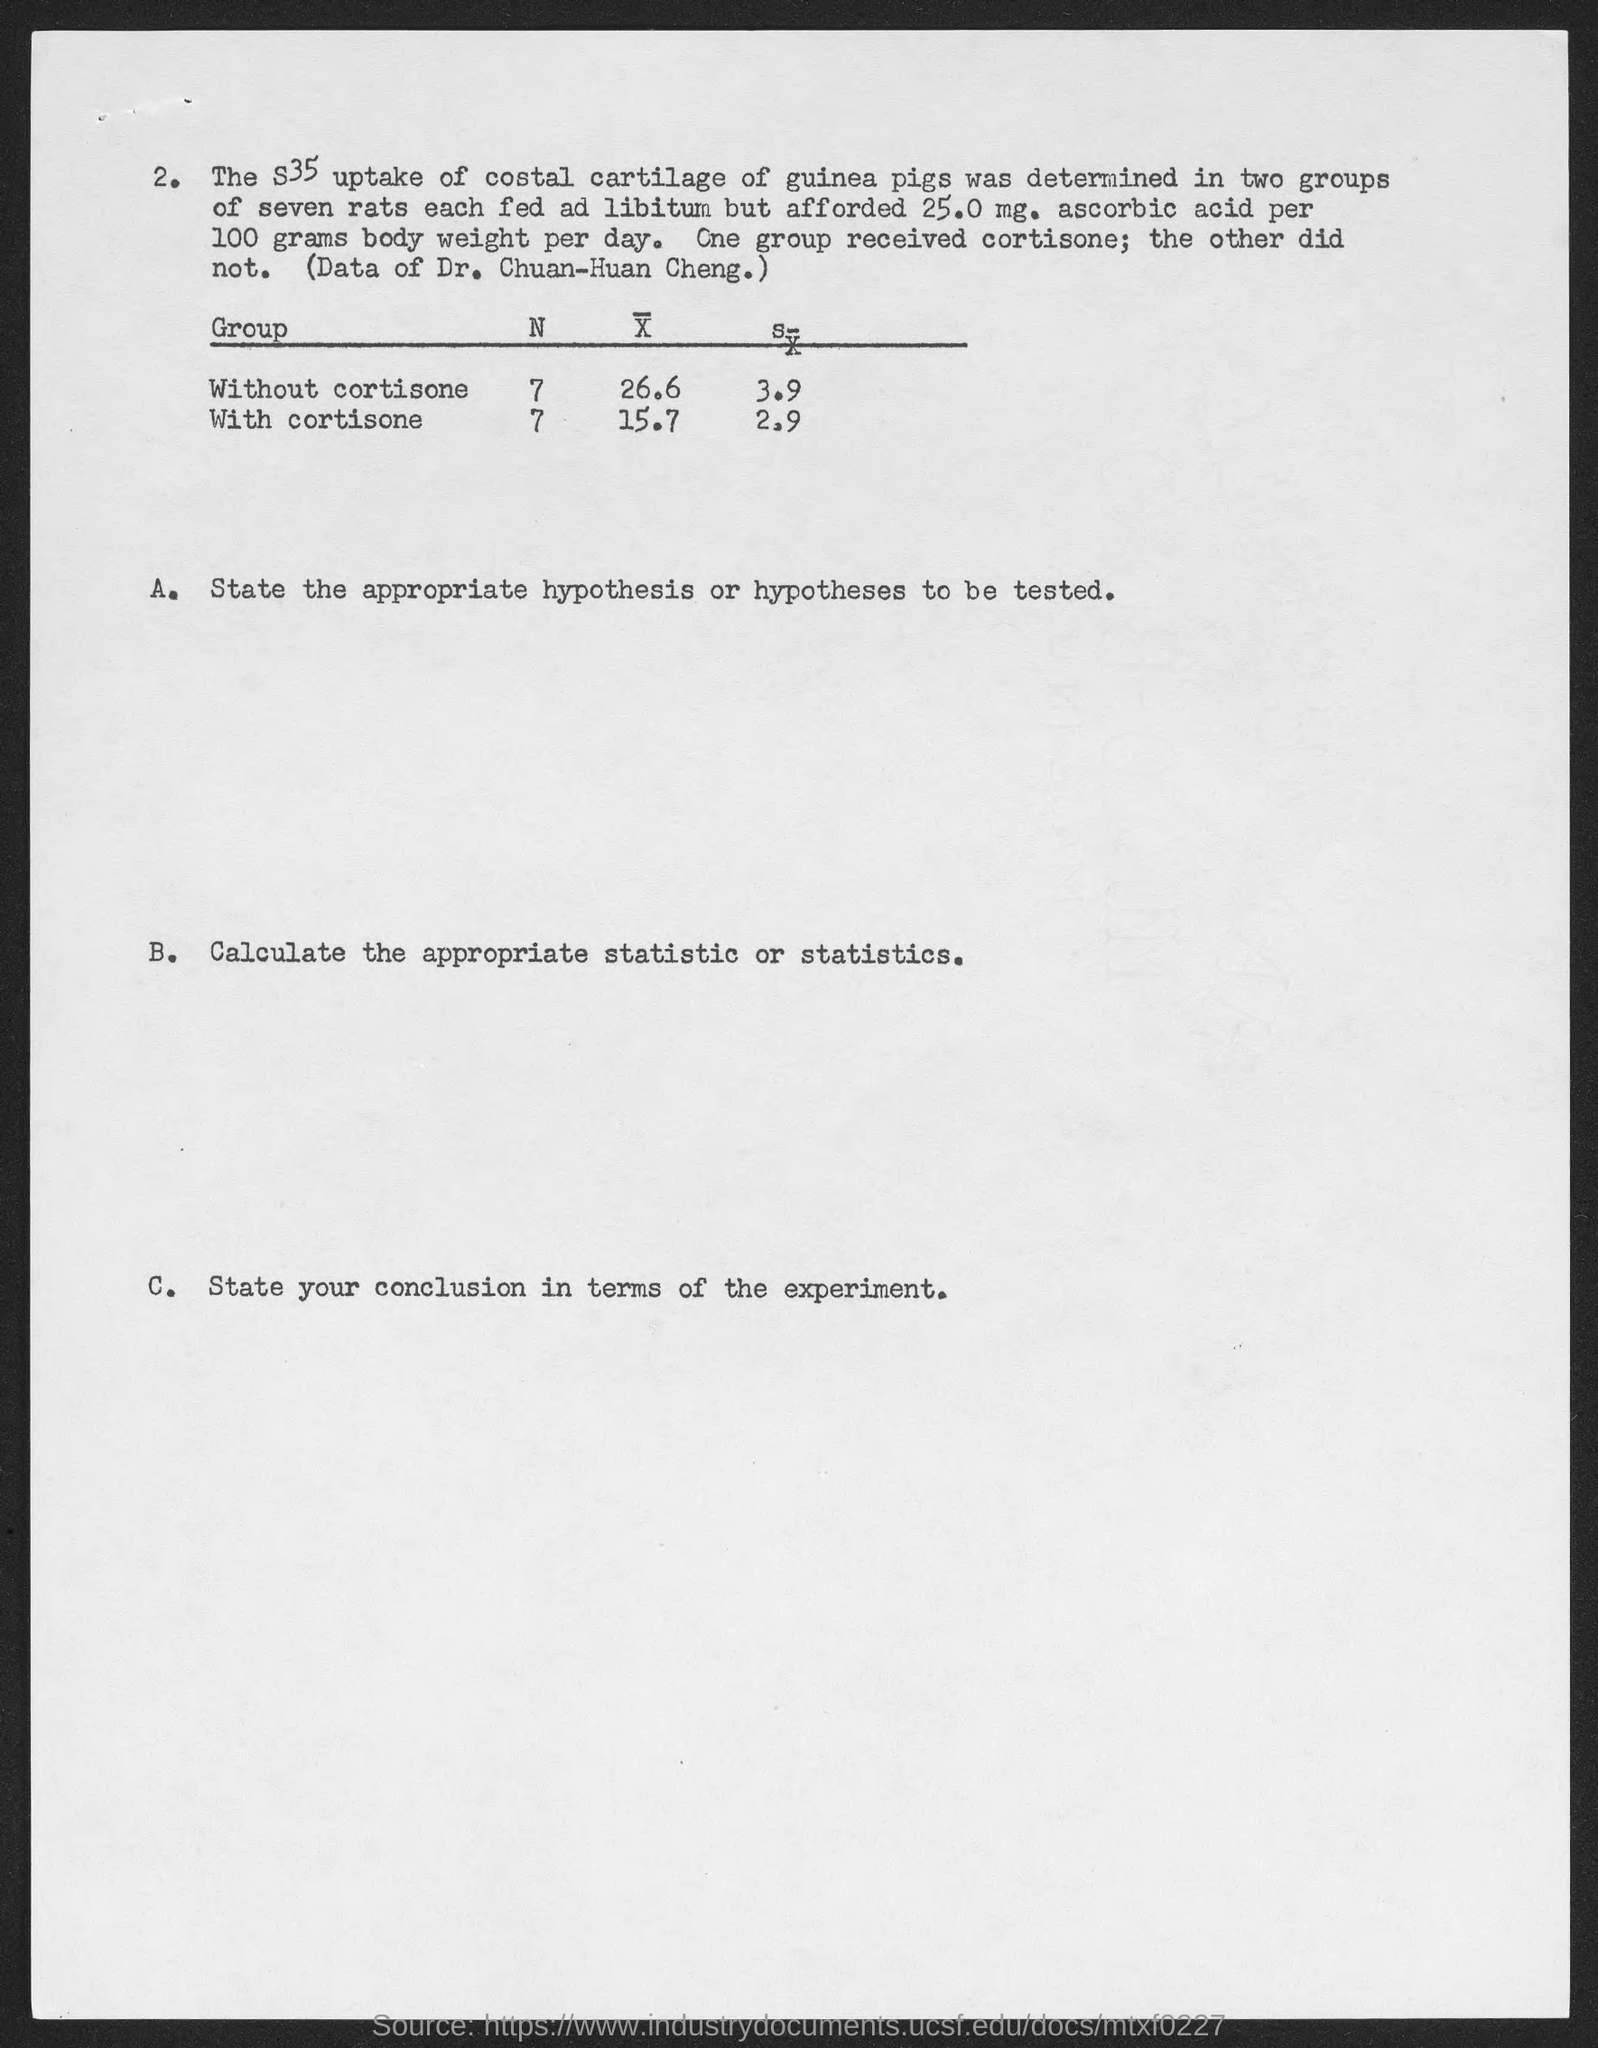What quantity of  "ascorbic acid per 100 gms body weight per day were given to the rats"?
Offer a terse response. 25.0 mg. Rats in "one group received" what?
Your response must be concise. Cortisone. Data prepared by whom is shown in the table?
Provide a succinct answer. DR. CHUAN-HUAN CHENG. Mention the heading of the first column of the table?
Give a very brief answer. GROUP. Which "Group" is first given in the table?
Offer a terse response. WITHOUT CORTISONE. Which "Group" is given second in the table?
Offer a very short reply. With cortisone. Mention the value of "N" for "Without cortisone" Group?
Your answer should be compact. 7. Mention the value of "N" for "With cortisone" Group?
Your response must be concise. 7. 